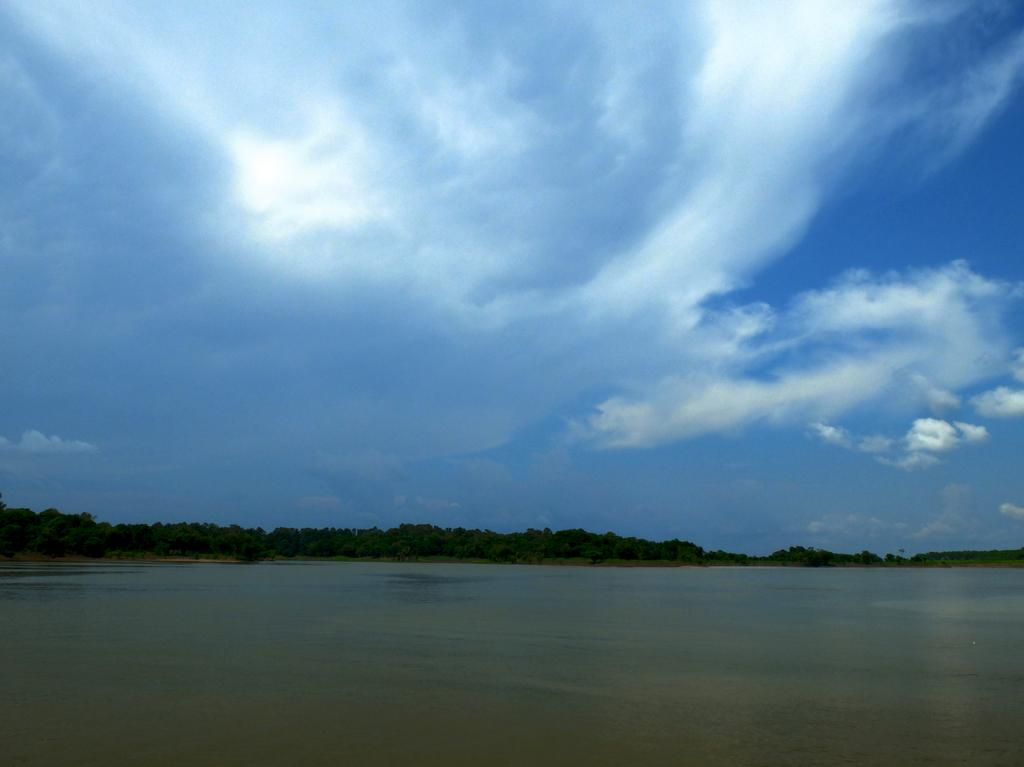What type of natural feature is shown in the image? There is a sea in the image. What can be seen behind the sea? There are trees visible behind the sea. What is visible in the sky at the top of the image? Clouds are present in the sky at the top of the image. Where is the crow using the cord to hang its toothbrush in the image? There is no crow, cord, or toothbrush present in the image. 